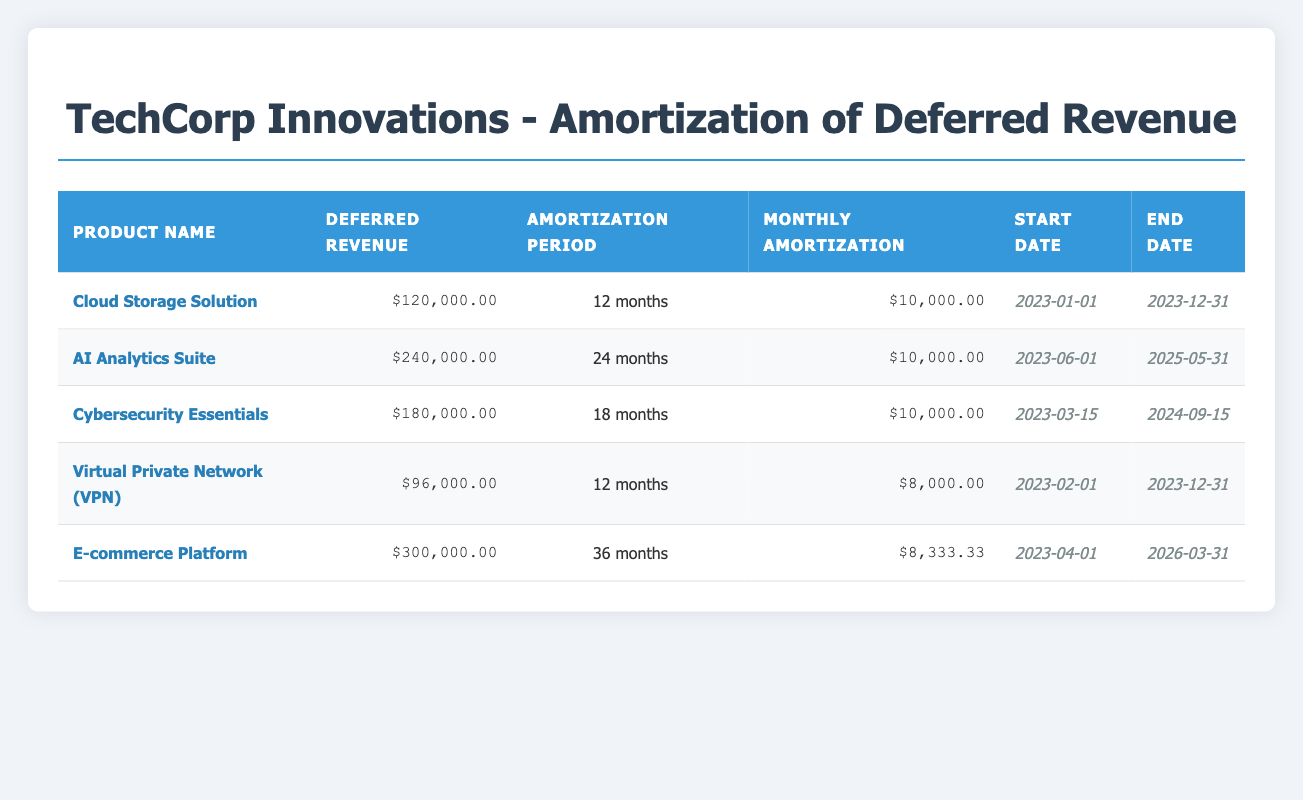What is the deferred revenue for the AI Analytics Suite? The deferred revenue for the AI Analytics Suite is listed in the table under the 'Deferred Revenue' column for that product. It is clearly stated as $240,000.00.
Answer: $240,000.00 How long is the amortization period for the Cloud Storage Solution? The amortization period for the Cloud Storage Solution is shown in the table under the 'Amortization Period' column. It states that the period is 12 months.
Answer: 12 months Which product has the highest deferred revenue and what is that amount? By examining the 'Deferred Revenue' column, we can see that the E-commerce Platform has the highest amount listed at $300,000.00.
Answer: E-commerce Platform, $300,000.00 What is the average monthly amortization amount across all products? To find the average monthly amortization, first sum the monthly amounts: (10,000 + 10,000 + 10,000 + 8,000 + 8,333.33) = 46,333.33. Then divide by the number of products (5): 46,333.33 / 5 = 9,266.67.
Answer: 9,266.67 Is the Cybersecurity Essentials product amortization period longer than that of the Virtual Private Network? The amortization period for Cybersecurity Essentials is 18 months, while for the Virtual Private Network, it is 12 months. Since 18 months is greater than 12 months, the statement is true.
Answer: Yes What is the total deferred revenue from all five products combined? To find the total deferred revenue, add up the amounts: 120,000 + 240,000 + 180,000 + 96,000 + 300,000 = 936,000.
Answer: $936,000 What is the difference in monthly amortization between the E-commerce Platform and the Cloud Storage Solution? The monthly amortization for the E-commerce Platform is 8,333.33, while for the Cloud Storage Solution, it is 10,000. To find the difference, subtract: 10,000 - 8,333.33 = 1,666.67.
Answer: 1,666.67 How many products have a monthly amortization amount of $10,000? In the table, the Cloud Storage Solution, AI Analytics Suite, and Cybersecurity Essentials all show a monthly amortization of $10,000. Count these products: there are 3.
Answer: 3 Does the AI Analytics Suite have a longer amortization period than the E-commerce Platform? The AI Analytics Suite has an amortization period of 24 months, while the E-commerce Platform has a period of 36 months. Since 24 months is less than 36 months, the statement is false.
Answer: No 